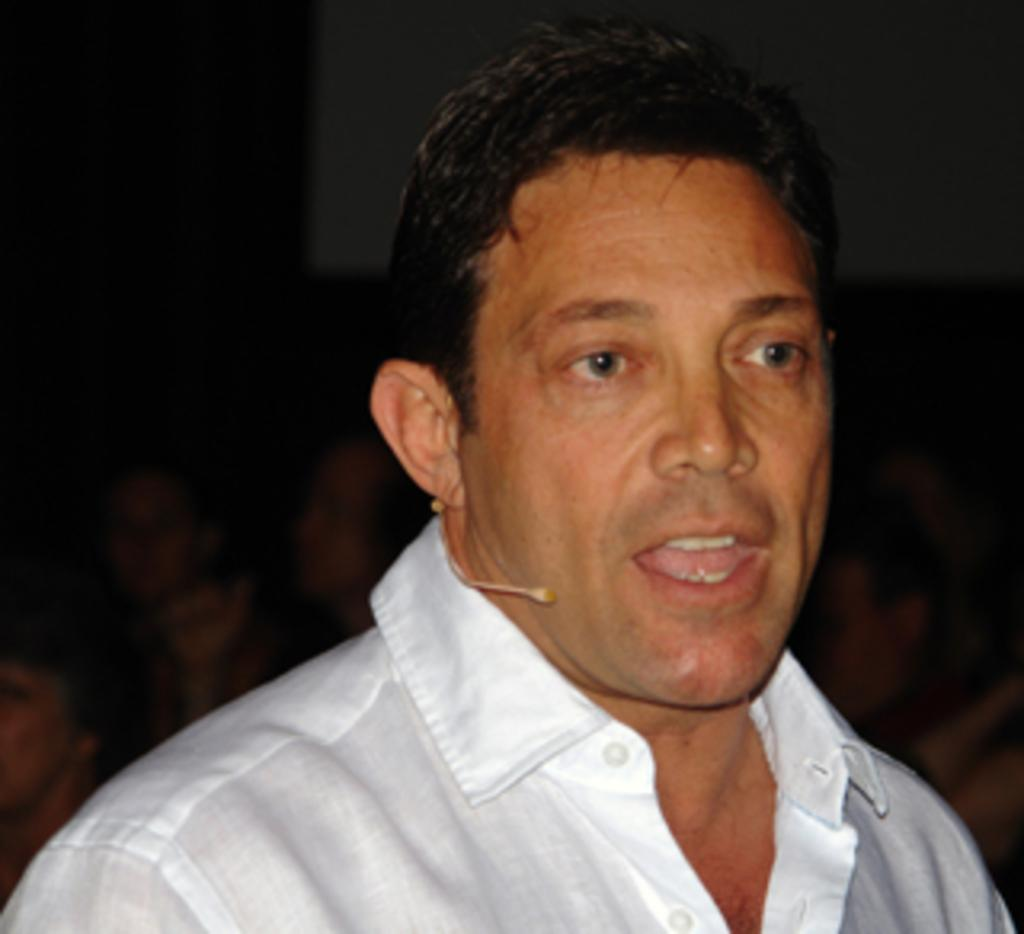What is the main subject of the image? There is a man standing in the image. Can you describe the background of the image? The background of the image is blurred. What type of fruit is the man holding in the image? There is no fruit present in the image; the man is not holding anything. What kind of soda is the man drinking in the image? There is no soda present in the image; the man is not drinking anything. 